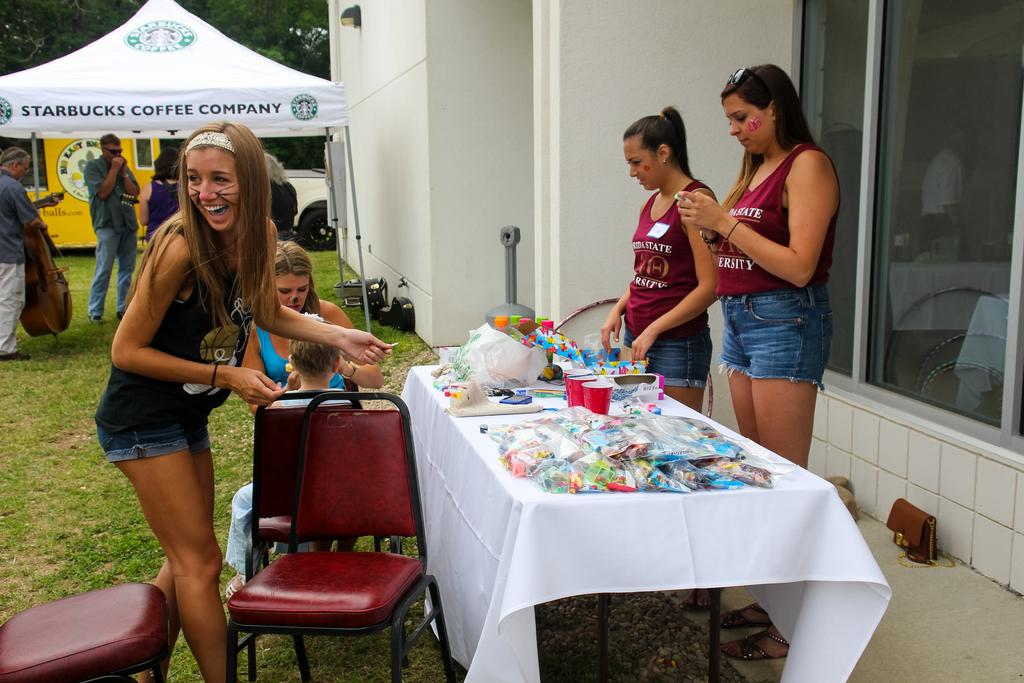What is the main subject of the image? The main subject of the image is a group of persons. Where are the persons located in the image? The group of persons is standing on the right side of the image. Can you describe the appearance of any specific individuals in the group? There are two persons wearing similar dress in the group. What else can be seen in the image besides the group of persons? There are items on top of a table in the image. What type of tax is being discussed by the group in the image? There is no indication in the image that the group is discussing any type of tax. 